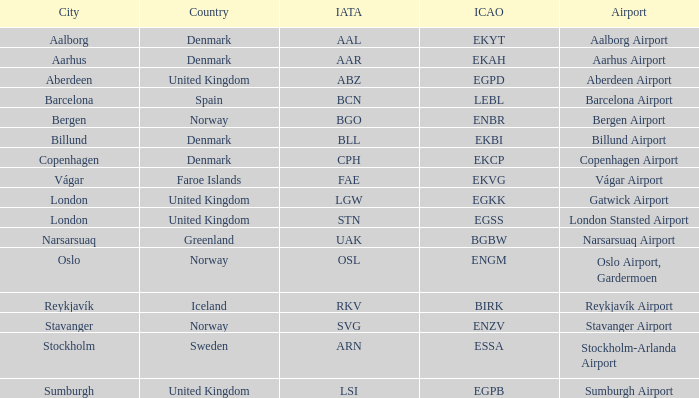What airport features an icap of bgbw? Narsarsuaq Airport. 